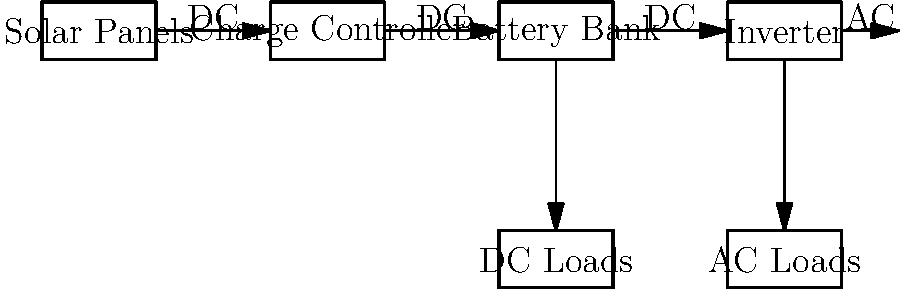As a politician advocating for sustainable housing solutions for immigrant communities, you're reviewing a residential solar power system. In the block diagram shown, which component is responsible for converting the DC power from the solar panels and battery bank into AC power suitable for standard household appliances? To answer this question, let's break down the components of the solar power system shown in the block diagram:

1. Solar Panels: These convert sunlight into DC (Direct Current) electricity.
2. Charge Controller: This regulates the voltage and current coming from the solar panels to safely charge the battery bank.
3. Battery Bank: This stores excess energy produced by the solar panels for use when sunlight is not available.
4. Inverter: This converts DC power from the solar panels and battery bank into AC (Alternating Current) power.
5. DC Loads: These are appliances that can run directly on DC power.
6. AC Loads: These are standard household appliances that require AC power.

The key component for converting DC power to AC power is the Inverter. This is crucial because most household appliances and the standard electrical grid operate on AC power. The inverter allows the DC power generated and stored in the system to be used by common household devices and to potentially feed back into the grid if there's excess power.

For immigrant communities seeking affordable and sustainable housing solutions, understanding this component is important. It allows for the use of standard appliances while still benefiting from the cost savings and environmental advantages of solar power.
Answer: Inverter 